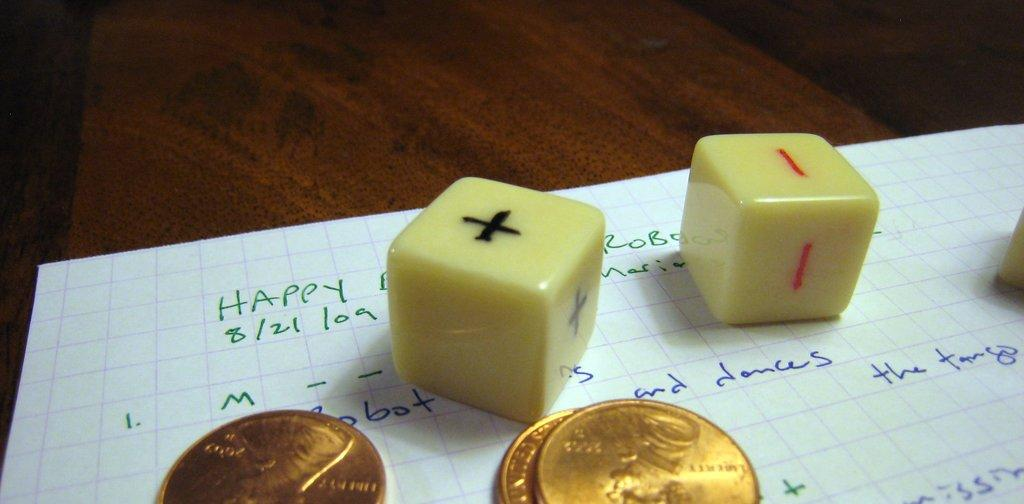<image>
Give a short and clear explanation of the subsequent image. On a sheet of paper is the word happy, some odd dice and a few coins. 